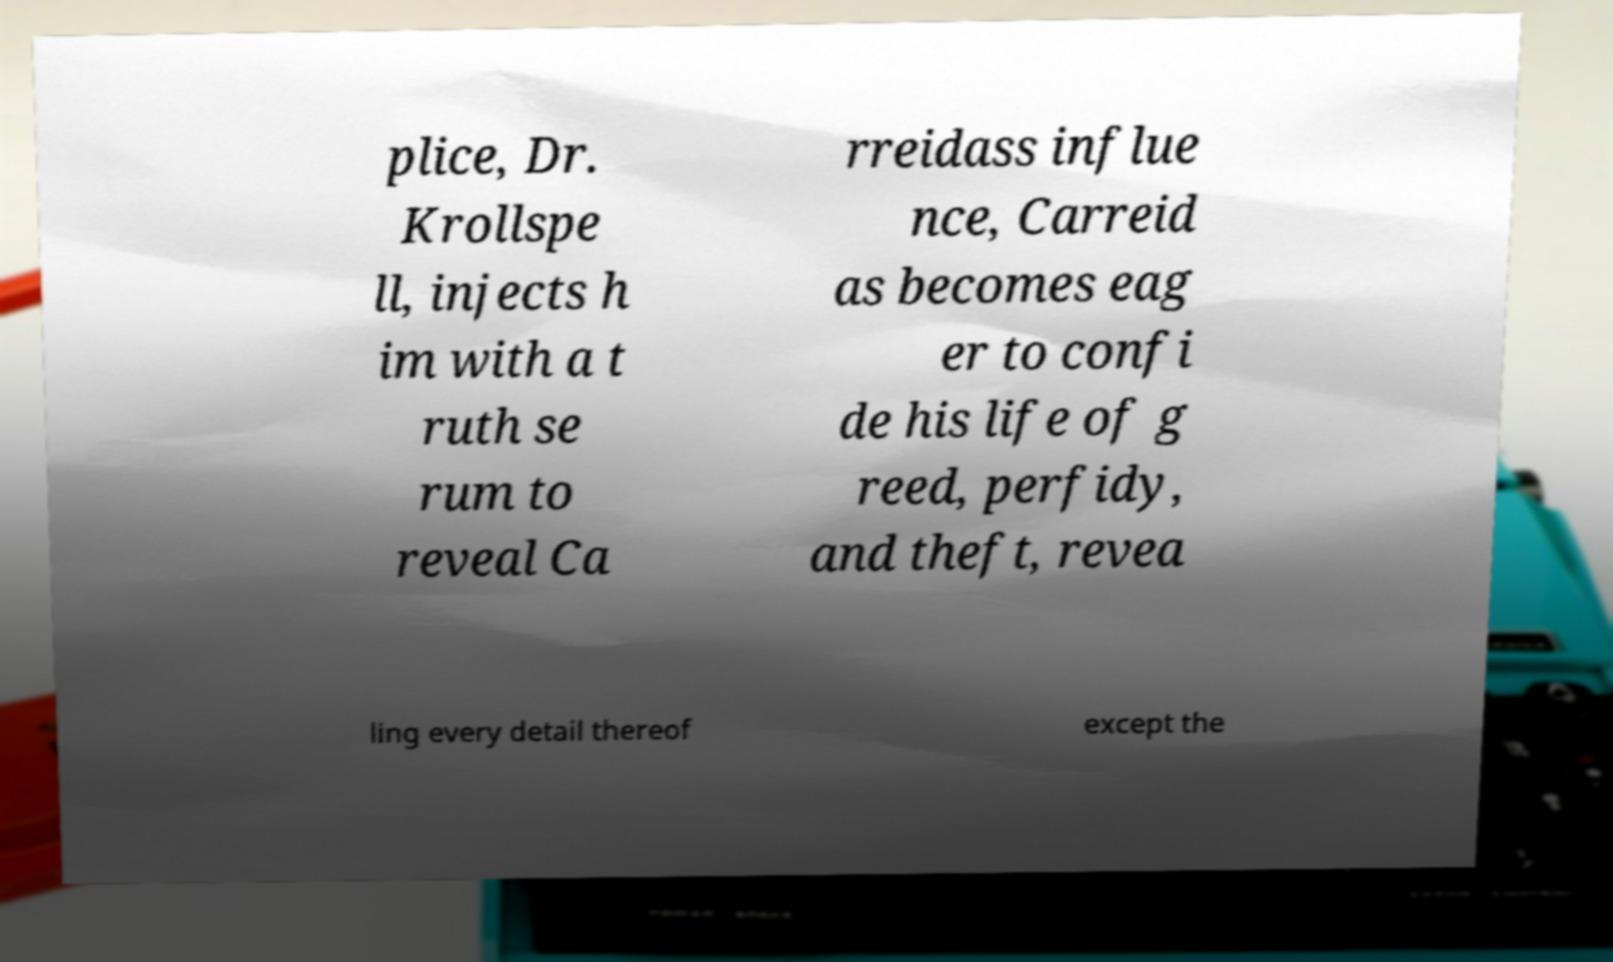Can you accurately transcribe the text from the provided image for me? plice, Dr. Krollspe ll, injects h im with a t ruth se rum to reveal Ca rreidass influe nce, Carreid as becomes eag er to confi de his life of g reed, perfidy, and theft, revea ling every detail thereof except the 